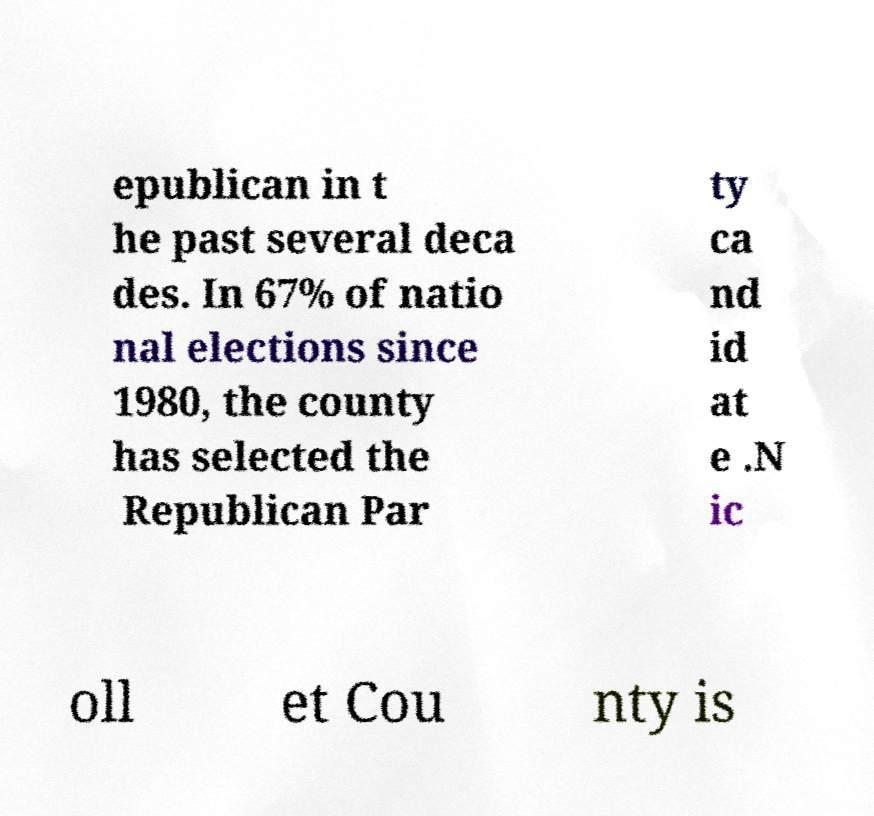Please read and relay the text visible in this image. What does it say? epublican in t he past several deca des. In 67% of natio nal elections since 1980, the county has selected the Republican Par ty ca nd id at e .N ic oll et Cou nty is 